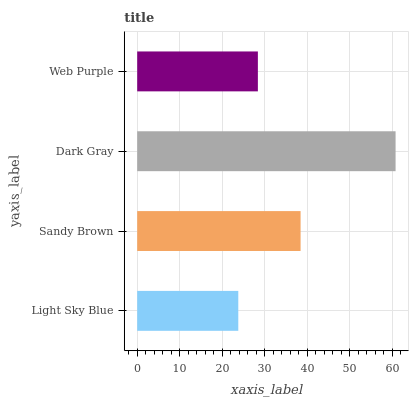Is Light Sky Blue the minimum?
Answer yes or no. Yes. Is Dark Gray the maximum?
Answer yes or no. Yes. Is Sandy Brown the minimum?
Answer yes or no. No. Is Sandy Brown the maximum?
Answer yes or no. No. Is Sandy Brown greater than Light Sky Blue?
Answer yes or no. Yes. Is Light Sky Blue less than Sandy Brown?
Answer yes or no. Yes. Is Light Sky Blue greater than Sandy Brown?
Answer yes or no. No. Is Sandy Brown less than Light Sky Blue?
Answer yes or no. No. Is Sandy Brown the high median?
Answer yes or no. Yes. Is Web Purple the low median?
Answer yes or no. Yes. Is Light Sky Blue the high median?
Answer yes or no. No. Is Sandy Brown the low median?
Answer yes or no. No. 